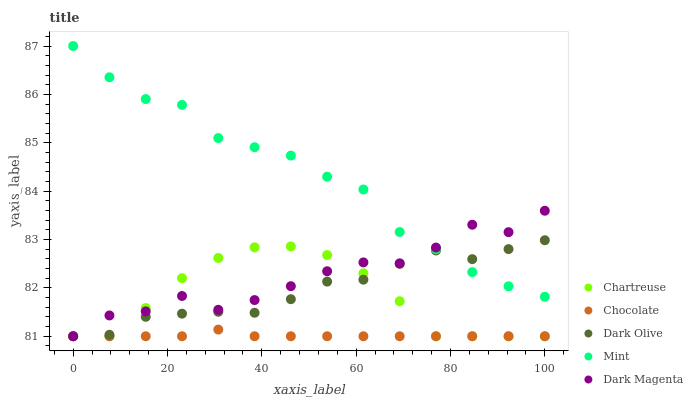Does Chocolate have the minimum area under the curve?
Answer yes or no. Yes. Does Mint have the maximum area under the curve?
Answer yes or no. Yes. Does Dark Olive have the minimum area under the curve?
Answer yes or no. No. Does Dark Olive have the maximum area under the curve?
Answer yes or no. No. Is Chocolate the smoothest?
Answer yes or no. Yes. Is Dark Magenta the roughest?
Answer yes or no. Yes. Is Dark Olive the smoothest?
Answer yes or no. No. Is Dark Olive the roughest?
Answer yes or no. No. Does Chartreuse have the lowest value?
Answer yes or no. Yes. Does Mint have the lowest value?
Answer yes or no. No. Does Mint have the highest value?
Answer yes or no. Yes. Does Dark Olive have the highest value?
Answer yes or no. No. Is Chocolate less than Mint?
Answer yes or no. Yes. Is Mint greater than Chocolate?
Answer yes or no. Yes. Does Chartreuse intersect Dark Olive?
Answer yes or no. Yes. Is Chartreuse less than Dark Olive?
Answer yes or no. No. Is Chartreuse greater than Dark Olive?
Answer yes or no. No. Does Chocolate intersect Mint?
Answer yes or no. No. 